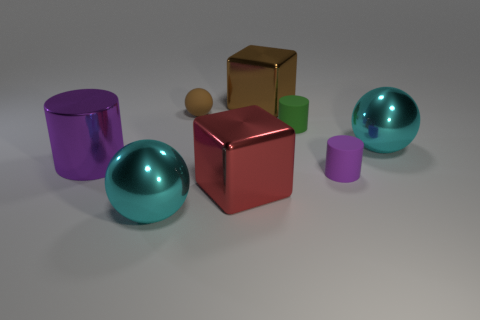Do the big metal cube behind the green matte cylinder and the tiny sphere have the same color?
Your answer should be very brief. Yes. What material is the large object that is both behind the tiny purple cylinder and to the left of the small brown thing?
Your answer should be very brief. Metal. There is a large shiny object right of the small purple rubber cylinder; is there a big brown block on the left side of it?
Provide a short and direct response. Yes. Is the material of the small purple cylinder the same as the red thing?
Give a very brief answer. No. What shape is the metal thing that is in front of the small ball and behind the big purple thing?
Provide a succinct answer. Sphere. There is a brown sphere that is behind the metal sphere in front of the big red object; what is its size?
Provide a succinct answer. Small. What number of tiny green rubber things have the same shape as the small purple matte object?
Provide a short and direct response. 1. Are there any other things that have the same shape as the brown matte thing?
Provide a succinct answer. Yes. Are there any large objects of the same color as the small sphere?
Your response must be concise. Yes. Are the cube that is on the left side of the big brown metal cube and the tiny cylinder behind the purple matte cylinder made of the same material?
Provide a succinct answer. No. 